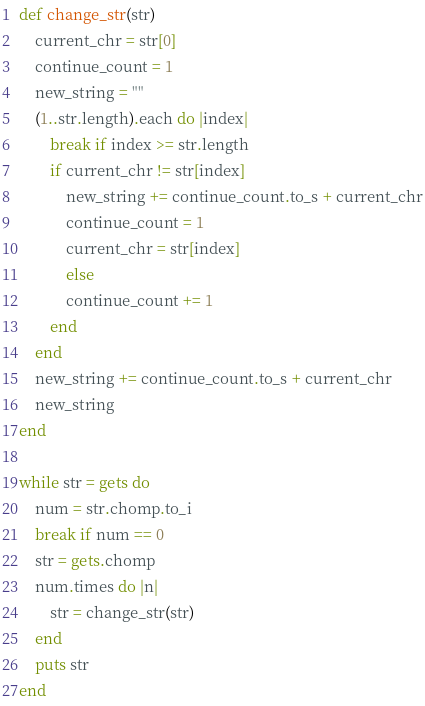Convert code to text. <code><loc_0><loc_0><loc_500><loc_500><_Ruby_>def change_str(str)
    current_chr = str[0]
    continue_count = 1
    new_string = ""
    (1..str.length).each do |index|
        break if index >= str.length
        if current_chr != str[index]
            new_string += continue_count.to_s + current_chr
            continue_count = 1
            current_chr = str[index]
            else
            continue_count += 1
        end
    end
    new_string += continue_count.to_s + current_chr
    new_string
end

while str = gets do
    num = str.chomp.to_i
    break if num == 0
    str = gets.chomp
    num.times do |n|
        str = change_str(str)
    end
    puts str
end</code> 